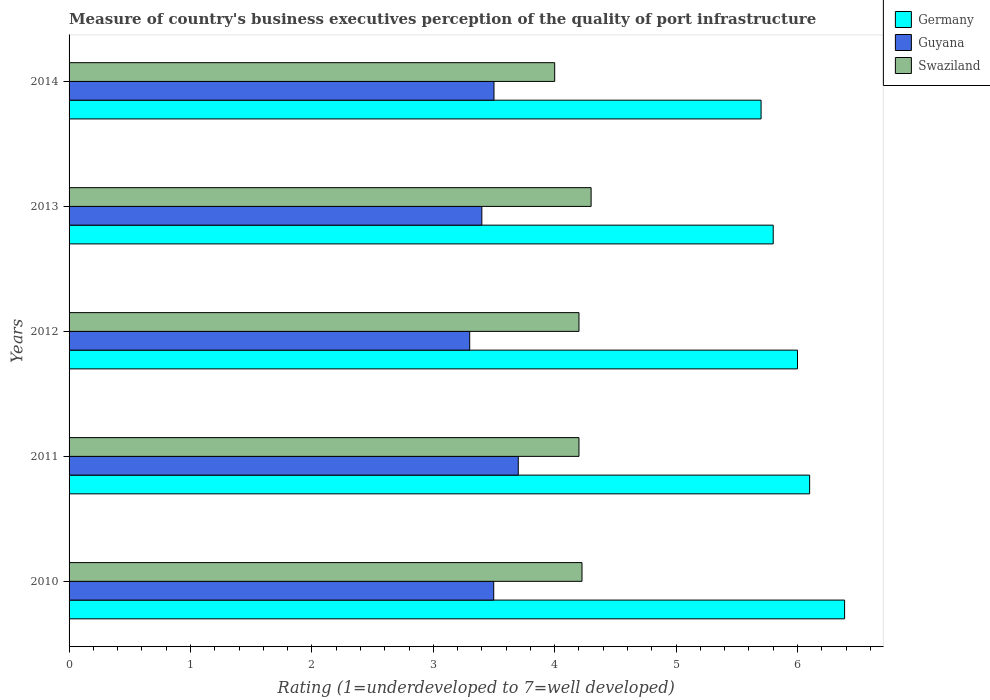Are the number of bars per tick equal to the number of legend labels?
Ensure brevity in your answer.  Yes. Are the number of bars on each tick of the Y-axis equal?
Your answer should be compact. Yes. What is the label of the 3rd group of bars from the top?
Your answer should be very brief. 2012. Across all years, what is the maximum ratings of the quality of port infrastructure in Germany?
Provide a short and direct response. 6.39. What is the total ratings of the quality of port infrastructure in Guyana in the graph?
Your answer should be compact. 17.4. What is the difference between the ratings of the quality of port infrastructure in Guyana in 2012 and that in 2013?
Provide a short and direct response. -0.1. What is the difference between the ratings of the quality of port infrastructure in Germany in 2011 and the ratings of the quality of port infrastructure in Guyana in 2013?
Your answer should be very brief. 2.7. What is the average ratings of the quality of port infrastructure in Guyana per year?
Make the answer very short. 3.48. In the year 2011, what is the difference between the ratings of the quality of port infrastructure in Swaziland and ratings of the quality of port infrastructure in Germany?
Offer a terse response. -1.9. What is the ratio of the ratings of the quality of port infrastructure in Guyana in 2010 to that in 2013?
Make the answer very short. 1.03. What is the difference between the highest and the second highest ratings of the quality of port infrastructure in Germany?
Keep it short and to the point. 0.29. What is the difference between the highest and the lowest ratings of the quality of port infrastructure in Guyana?
Provide a succinct answer. 0.4. What does the 3rd bar from the top in 2012 represents?
Your answer should be very brief. Germany. What does the 2nd bar from the bottom in 2014 represents?
Give a very brief answer. Guyana. How many bars are there?
Keep it short and to the point. 15. Are all the bars in the graph horizontal?
Keep it short and to the point. Yes. What is the difference between two consecutive major ticks on the X-axis?
Keep it short and to the point. 1. Does the graph contain any zero values?
Your response must be concise. No. How many legend labels are there?
Keep it short and to the point. 3. What is the title of the graph?
Your answer should be compact. Measure of country's business executives perception of the quality of port infrastructure. What is the label or title of the X-axis?
Provide a succinct answer. Rating (1=underdeveloped to 7=well developed). What is the label or title of the Y-axis?
Your answer should be compact. Years. What is the Rating (1=underdeveloped to 7=well developed) in Germany in 2010?
Provide a succinct answer. 6.39. What is the Rating (1=underdeveloped to 7=well developed) in Guyana in 2010?
Your response must be concise. 3.5. What is the Rating (1=underdeveloped to 7=well developed) in Swaziland in 2010?
Make the answer very short. 4.23. What is the Rating (1=underdeveloped to 7=well developed) in Germany in 2011?
Ensure brevity in your answer.  6.1. What is the Rating (1=underdeveloped to 7=well developed) in Swaziland in 2011?
Provide a short and direct response. 4.2. What is the Rating (1=underdeveloped to 7=well developed) in Germany in 2012?
Provide a short and direct response. 6. What is the Rating (1=underdeveloped to 7=well developed) in Swaziland in 2012?
Your answer should be compact. 4.2. What is the Rating (1=underdeveloped to 7=well developed) of Germany in 2013?
Make the answer very short. 5.8. What is the Rating (1=underdeveloped to 7=well developed) in Swaziland in 2013?
Your response must be concise. 4.3. What is the Rating (1=underdeveloped to 7=well developed) in Germany in 2014?
Keep it short and to the point. 5.7. What is the Rating (1=underdeveloped to 7=well developed) of Swaziland in 2014?
Provide a short and direct response. 4. Across all years, what is the maximum Rating (1=underdeveloped to 7=well developed) in Germany?
Ensure brevity in your answer.  6.39. Across all years, what is the maximum Rating (1=underdeveloped to 7=well developed) in Guyana?
Give a very brief answer. 3.7. Across all years, what is the maximum Rating (1=underdeveloped to 7=well developed) in Swaziland?
Make the answer very short. 4.3. What is the total Rating (1=underdeveloped to 7=well developed) in Germany in the graph?
Provide a succinct answer. 29.99. What is the total Rating (1=underdeveloped to 7=well developed) in Guyana in the graph?
Make the answer very short. 17.4. What is the total Rating (1=underdeveloped to 7=well developed) in Swaziland in the graph?
Give a very brief answer. 20.93. What is the difference between the Rating (1=underdeveloped to 7=well developed) in Germany in 2010 and that in 2011?
Make the answer very short. 0.29. What is the difference between the Rating (1=underdeveloped to 7=well developed) of Guyana in 2010 and that in 2011?
Keep it short and to the point. -0.2. What is the difference between the Rating (1=underdeveloped to 7=well developed) in Swaziland in 2010 and that in 2011?
Keep it short and to the point. 0.03. What is the difference between the Rating (1=underdeveloped to 7=well developed) of Germany in 2010 and that in 2012?
Ensure brevity in your answer.  0.39. What is the difference between the Rating (1=underdeveloped to 7=well developed) in Guyana in 2010 and that in 2012?
Provide a succinct answer. 0.2. What is the difference between the Rating (1=underdeveloped to 7=well developed) in Swaziland in 2010 and that in 2012?
Your response must be concise. 0.03. What is the difference between the Rating (1=underdeveloped to 7=well developed) in Germany in 2010 and that in 2013?
Provide a short and direct response. 0.59. What is the difference between the Rating (1=underdeveloped to 7=well developed) in Guyana in 2010 and that in 2013?
Your answer should be very brief. 0.1. What is the difference between the Rating (1=underdeveloped to 7=well developed) in Swaziland in 2010 and that in 2013?
Offer a terse response. -0.07. What is the difference between the Rating (1=underdeveloped to 7=well developed) in Germany in 2010 and that in 2014?
Your answer should be very brief. 0.69. What is the difference between the Rating (1=underdeveloped to 7=well developed) of Guyana in 2010 and that in 2014?
Give a very brief answer. -0. What is the difference between the Rating (1=underdeveloped to 7=well developed) in Swaziland in 2010 and that in 2014?
Provide a short and direct response. 0.23. What is the difference between the Rating (1=underdeveloped to 7=well developed) of Germany in 2011 and that in 2012?
Offer a terse response. 0.1. What is the difference between the Rating (1=underdeveloped to 7=well developed) in Guyana in 2011 and that in 2012?
Keep it short and to the point. 0.4. What is the difference between the Rating (1=underdeveloped to 7=well developed) in Germany in 2011 and that in 2013?
Your answer should be compact. 0.3. What is the difference between the Rating (1=underdeveloped to 7=well developed) in Swaziland in 2011 and that in 2013?
Offer a terse response. -0.1. What is the difference between the Rating (1=underdeveloped to 7=well developed) of Germany in 2011 and that in 2014?
Your response must be concise. 0.4. What is the difference between the Rating (1=underdeveloped to 7=well developed) of Germany in 2012 and that in 2013?
Give a very brief answer. 0.2. What is the difference between the Rating (1=underdeveloped to 7=well developed) of Guyana in 2012 and that in 2013?
Ensure brevity in your answer.  -0.1. What is the difference between the Rating (1=underdeveloped to 7=well developed) in Swaziland in 2012 and that in 2013?
Keep it short and to the point. -0.1. What is the difference between the Rating (1=underdeveloped to 7=well developed) in Swaziland in 2012 and that in 2014?
Your response must be concise. 0.2. What is the difference between the Rating (1=underdeveloped to 7=well developed) of Germany in 2013 and that in 2014?
Provide a short and direct response. 0.1. What is the difference between the Rating (1=underdeveloped to 7=well developed) of Germany in 2010 and the Rating (1=underdeveloped to 7=well developed) of Guyana in 2011?
Provide a short and direct response. 2.69. What is the difference between the Rating (1=underdeveloped to 7=well developed) in Germany in 2010 and the Rating (1=underdeveloped to 7=well developed) in Swaziland in 2011?
Provide a short and direct response. 2.19. What is the difference between the Rating (1=underdeveloped to 7=well developed) of Guyana in 2010 and the Rating (1=underdeveloped to 7=well developed) of Swaziland in 2011?
Offer a terse response. -0.7. What is the difference between the Rating (1=underdeveloped to 7=well developed) in Germany in 2010 and the Rating (1=underdeveloped to 7=well developed) in Guyana in 2012?
Provide a succinct answer. 3.09. What is the difference between the Rating (1=underdeveloped to 7=well developed) of Germany in 2010 and the Rating (1=underdeveloped to 7=well developed) of Swaziland in 2012?
Provide a succinct answer. 2.19. What is the difference between the Rating (1=underdeveloped to 7=well developed) in Guyana in 2010 and the Rating (1=underdeveloped to 7=well developed) in Swaziland in 2012?
Your response must be concise. -0.7. What is the difference between the Rating (1=underdeveloped to 7=well developed) in Germany in 2010 and the Rating (1=underdeveloped to 7=well developed) in Guyana in 2013?
Your answer should be very brief. 2.99. What is the difference between the Rating (1=underdeveloped to 7=well developed) in Germany in 2010 and the Rating (1=underdeveloped to 7=well developed) in Swaziland in 2013?
Your response must be concise. 2.09. What is the difference between the Rating (1=underdeveloped to 7=well developed) in Guyana in 2010 and the Rating (1=underdeveloped to 7=well developed) in Swaziland in 2013?
Keep it short and to the point. -0.8. What is the difference between the Rating (1=underdeveloped to 7=well developed) of Germany in 2010 and the Rating (1=underdeveloped to 7=well developed) of Guyana in 2014?
Ensure brevity in your answer.  2.89. What is the difference between the Rating (1=underdeveloped to 7=well developed) in Germany in 2010 and the Rating (1=underdeveloped to 7=well developed) in Swaziland in 2014?
Provide a succinct answer. 2.39. What is the difference between the Rating (1=underdeveloped to 7=well developed) of Guyana in 2010 and the Rating (1=underdeveloped to 7=well developed) of Swaziland in 2014?
Offer a terse response. -0.5. What is the difference between the Rating (1=underdeveloped to 7=well developed) of Germany in 2011 and the Rating (1=underdeveloped to 7=well developed) of Guyana in 2012?
Your response must be concise. 2.8. What is the difference between the Rating (1=underdeveloped to 7=well developed) in Germany in 2011 and the Rating (1=underdeveloped to 7=well developed) in Swaziland in 2012?
Provide a succinct answer. 1.9. What is the difference between the Rating (1=underdeveloped to 7=well developed) in Germany in 2011 and the Rating (1=underdeveloped to 7=well developed) in Swaziland in 2013?
Offer a terse response. 1.8. What is the difference between the Rating (1=underdeveloped to 7=well developed) in Guyana in 2011 and the Rating (1=underdeveloped to 7=well developed) in Swaziland in 2013?
Your response must be concise. -0.6. What is the difference between the Rating (1=underdeveloped to 7=well developed) of Germany in 2011 and the Rating (1=underdeveloped to 7=well developed) of Swaziland in 2014?
Keep it short and to the point. 2.1. What is the difference between the Rating (1=underdeveloped to 7=well developed) of Germany in 2012 and the Rating (1=underdeveloped to 7=well developed) of Swaziland in 2013?
Provide a succinct answer. 1.7. What is the difference between the Rating (1=underdeveloped to 7=well developed) in Guyana in 2012 and the Rating (1=underdeveloped to 7=well developed) in Swaziland in 2013?
Your response must be concise. -1. What is the difference between the Rating (1=underdeveloped to 7=well developed) of Guyana in 2012 and the Rating (1=underdeveloped to 7=well developed) of Swaziland in 2014?
Your answer should be very brief. -0.7. What is the difference between the Rating (1=underdeveloped to 7=well developed) in Germany in 2013 and the Rating (1=underdeveloped to 7=well developed) in Guyana in 2014?
Keep it short and to the point. 2.3. What is the difference between the Rating (1=underdeveloped to 7=well developed) in Guyana in 2013 and the Rating (1=underdeveloped to 7=well developed) in Swaziland in 2014?
Make the answer very short. -0.6. What is the average Rating (1=underdeveloped to 7=well developed) of Germany per year?
Provide a succinct answer. 6. What is the average Rating (1=underdeveloped to 7=well developed) in Guyana per year?
Offer a terse response. 3.48. What is the average Rating (1=underdeveloped to 7=well developed) of Swaziland per year?
Your response must be concise. 4.18. In the year 2010, what is the difference between the Rating (1=underdeveloped to 7=well developed) of Germany and Rating (1=underdeveloped to 7=well developed) of Guyana?
Your response must be concise. 2.89. In the year 2010, what is the difference between the Rating (1=underdeveloped to 7=well developed) of Germany and Rating (1=underdeveloped to 7=well developed) of Swaziland?
Provide a short and direct response. 2.16. In the year 2010, what is the difference between the Rating (1=underdeveloped to 7=well developed) in Guyana and Rating (1=underdeveloped to 7=well developed) in Swaziland?
Your response must be concise. -0.73. In the year 2011, what is the difference between the Rating (1=underdeveloped to 7=well developed) in Guyana and Rating (1=underdeveloped to 7=well developed) in Swaziland?
Your response must be concise. -0.5. In the year 2012, what is the difference between the Rating (1=underdeveloped to 7=well developed) of Germany and Rating (1=underdeveloped to 7=well developed) of Swaziland?
Offer a very short reply. 1.8. In the year 2012, what is the difference between the Rating (1=underdeveloped to 7=well developed) of Guyana and Rating (1=underdeveloped to 7=well developed) of Swaziland?
Provide a short and direct response. -0.9. In the year 2013, what is the difference between the Rating (1=underdeveloped to 7=well developed) in Germany and Rating (1=underdeveloped to 7=well developed) in Swaziland?
Your answer should be very brief. 1.5. In the year 2014, what is the difference between the Rating (1=underdeveloped to 7=well developed) of Germany and Rating (1=underdeveloped to 7=well developed) of Swaziland?
Keep it short and to the point. 1.7. In the year 2014, what is the difference between the Rating (1=underdeveloped to 7=well developed) in Guyana and Rating (1=underdeveloped to 7=well developed) in Swaziland?
Provide a short and direct response. -0.5. What is the ratio of the Rating (1=underdeveloped to 7=well developed) in Germany in 2010 to that in 2011?
Give a very brief answer. 1.05. What is the ratio of the Rating (1=underdeveloped to 7=well developed) of Guyana in 2010 to that in 2011?
Offer a very short reply. 0.95. What is the ratio of the Rating (1=underdeveloped to 7=well developed) of Swaziland in 2010 to that in 2011?
Provide a succinct answer. 1.01. What is the ratio of the Rating (1=underdeveloped to 7=well developed) of Germany in 2010 to that in 2012?
Offer a terse response. 1.06. What is the ratio of the Rating (1=underdeveloped to 7=well developed) of Guyana in 2010 to that in 2012?
Give a very brief answer. 1.06. What is the ratio of the Rating (1=underdeveloped to 7=well developed) of Germany in 2010 to that in 2013?
Your answer should be very brief. 1.1. What is the ratio of the Rating (1=underdeveloped to 7=well developed) of Guyana in 2010 to that in 2013?
Offer a very short reply. 1.03. What is the ratio of the Rating (1=underdeveloped to 7=well developed) in Swaziland in 2010 to that in 2013?
Provide a short and direct response. 0.98. What is the ratio of the Rating (1=underdeveloped to 7=well developed) in Germany in 2010 to that in 2014?
Keep it short and to the point. 1.12. What is the ratio of the Rating (1=underdeveloped to 7=well developed) of Guyana in 2010 to that in 2014?
Keep it short and to the point. 1. What is the ratio of the Rating (1=underdeveloped to 7=well developed) of Swaziland in 2010 to that in 2014?
Provide a short and direct response. 1.06. What is the ratio of the Rating (1=underdeveloped to 7=well developed) in Germany in 2011 to that in 2012?
Keep it short and to the point. 1.02. What is the ratio of the Rating (1=underdeveloped to 7=well developed) of Guyana in 2011 to that in 2012?
Offer a terse response. 1.12. What is the ratio of the Rating (1=underdeveloped to 7=well developed) of Swaziland in 2011 to that in 2012?
Provide a short and direct response. 1. What is the ratio of the Rating (1=underdeveloped to 7=well developed) in Germany in 2011 to that in 2013?
Your response must be concise. 1.05. What is the ratio of the Rating (1=underdeveloped to 7=well developed) of Guyana in 2011 to that in 2013?
Ensure brevity in your answer.  1.09. What is the ratio of the Rating (1=underdeveloped to 7=well developed) in Swaziland in 2011 to that in 2013?
Provide a short and direct response. 0.98. What is the ratio of the Rating (1=underdeveloped to 7=well developed) of Germany in 2011 to that in 2014?
Give a very brief answer. 1.07. What is the ratio of the Rating (1=underdeveloped to 7=well developed) in Guyana in 2011 to that in 2014?
Ensure brevity in your answer.  1.06. What is the ratio of the Rating (1=underdeveloped to 7=well developed) of Germany in 2012 to that in 2013?
Offer a very short reply. 1.03. What is the ratio of the Rating (1=underdeveloped to 7=well developed) in Guyana in 2012 to that in 2013?
Your answer should be very brief. 0.97. What is the ratio of the Rating (1=underdeveloped to 7=well developed) of Swaziland in 2012 to that in 2013?
Your answer should be compact. 0.98. What is the ratio of the Rating (1=underdeveloped to 7=well developed) in Germany in 2012 to that in 2014?
Ensure brevity in your answer.  1.05. What is the ratio of the Rating (1=underdeveloped to 7=well developed) of Guyana in 2012 to that in 2014?
Keep it short and to the point. 0.94. What is the ratio of the Rating (1=underdeveloped to 7=well developed) in Swaziland in 2012 to that in 2014?
Your answer should be very brief. 1.05. What is the ratio of the Rating (1=underdeveloped to 7=well developed) of Germany in 2013 to that in 2014?
Keep it short and to the point. 1.02. What is the ratio of the Rating (1=underdeveloped to 7=well developed) of Guyana in 2013 to that in 2014?
Give a very brief answer. 0.97. What is the ratio of the Rating (1=underdeveloped to 7=well developed) in Swaziland in 2013 to that in 2014?
Provide a succinct answer. 1.07. What is the difference between the highest and the second highest Rating (1=underdeveloped to 7=well developed) of Germany?
Ensure brevity in your answer.  0.29. What is the difference between the highest and the second highest Rating (1=underdeveloped to 7=well developed) in Swaziland?
Give a very brief answer. 0.07. What is the difference between the highest and the lowest Rating (1=underdeveloped to 7=well developed) of Germany?
Your answer should be compact. 0.69. What is the difference between the highest and the lowest Rating (1=underdeveloped to 7=well developed) in Swaziland?
Provide a succinct answer. 0.3. 